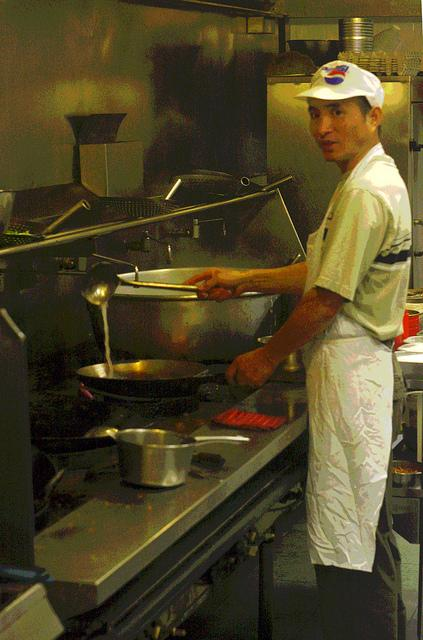What style food is most likely being prepared in this kitchen? chinese 